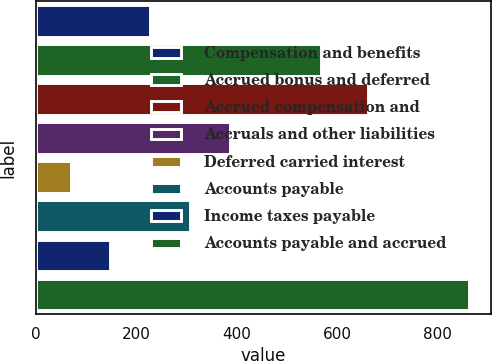<chart> <loc_0><loc_0><loc_500><loc_500><bar_chart><fcel>Compensation and benefits<fcel>Accrued bonus and deferred<fcel>Accrued compensation and<fcel>Accruals and other liabilities<fcel>Deferred carried interest<fcel>Accounts payable<fcel>Income taxes payable<fcel>Accounts payable and accrued<nl><fcel>227.98<fcel>568.1<fcel>661.3<fcel>386.76<fcel>69.2<fcel>307.37<fcel>148.59<fcel>863.1<nl></chart> 